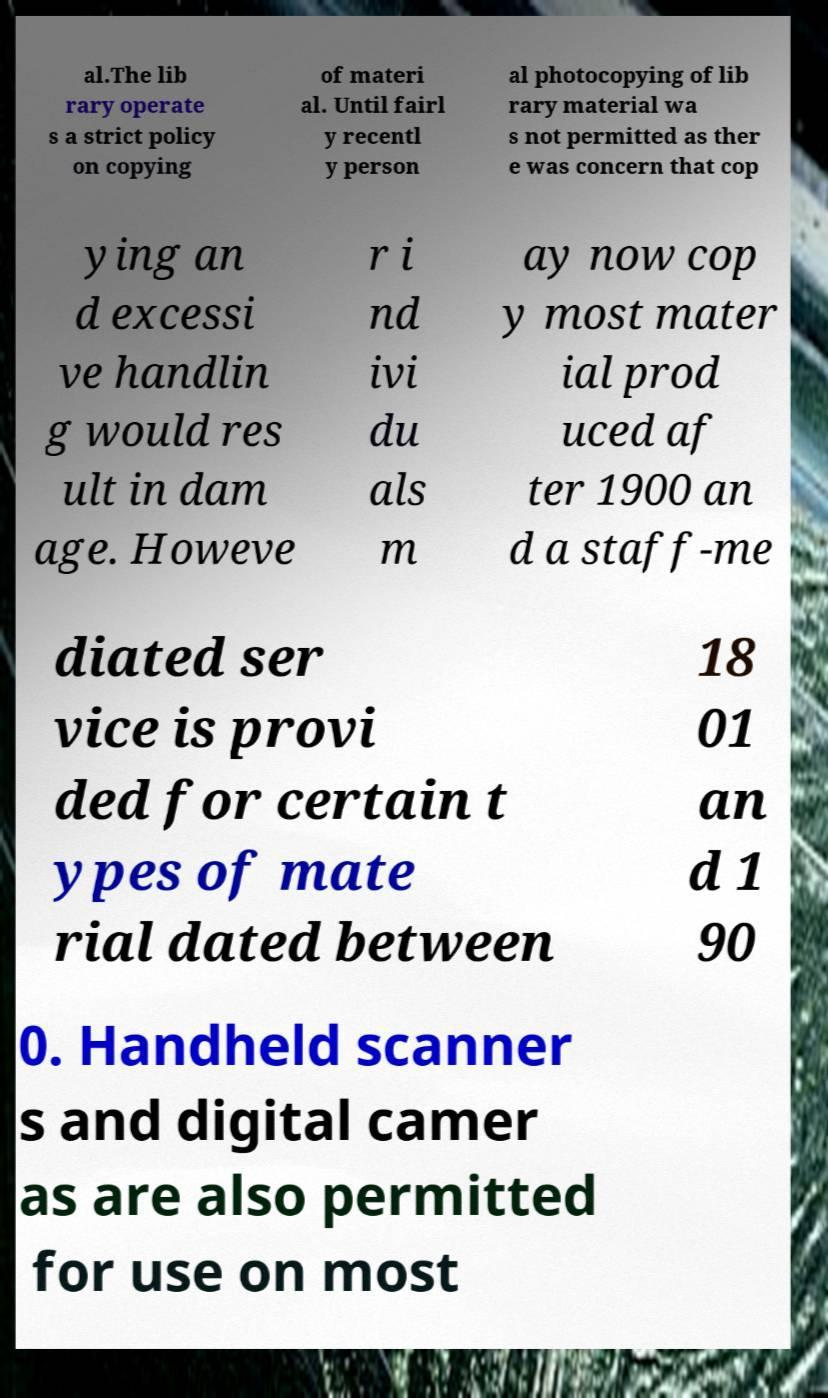What messages or text are displayed in this image? I need them in a readable, typed format. al.The lib rary operate s a strict policy on copying of materi al. Until fairl y recentl y person al photocopying of lib rary material wa s not permitted as ther e was concern that cop ying an d excessi ve handlin g would res ult in dam age. Howeve r i nd ivi du als m ay now cop y most mater ial prod uced af ter 1900 an d a staff-me diated ser vice is provi ded for certain t ypes of mate rial dated between 18 01 an d 1 90 0. Handheld scanner s and digital camer as are also permitted for use on most 